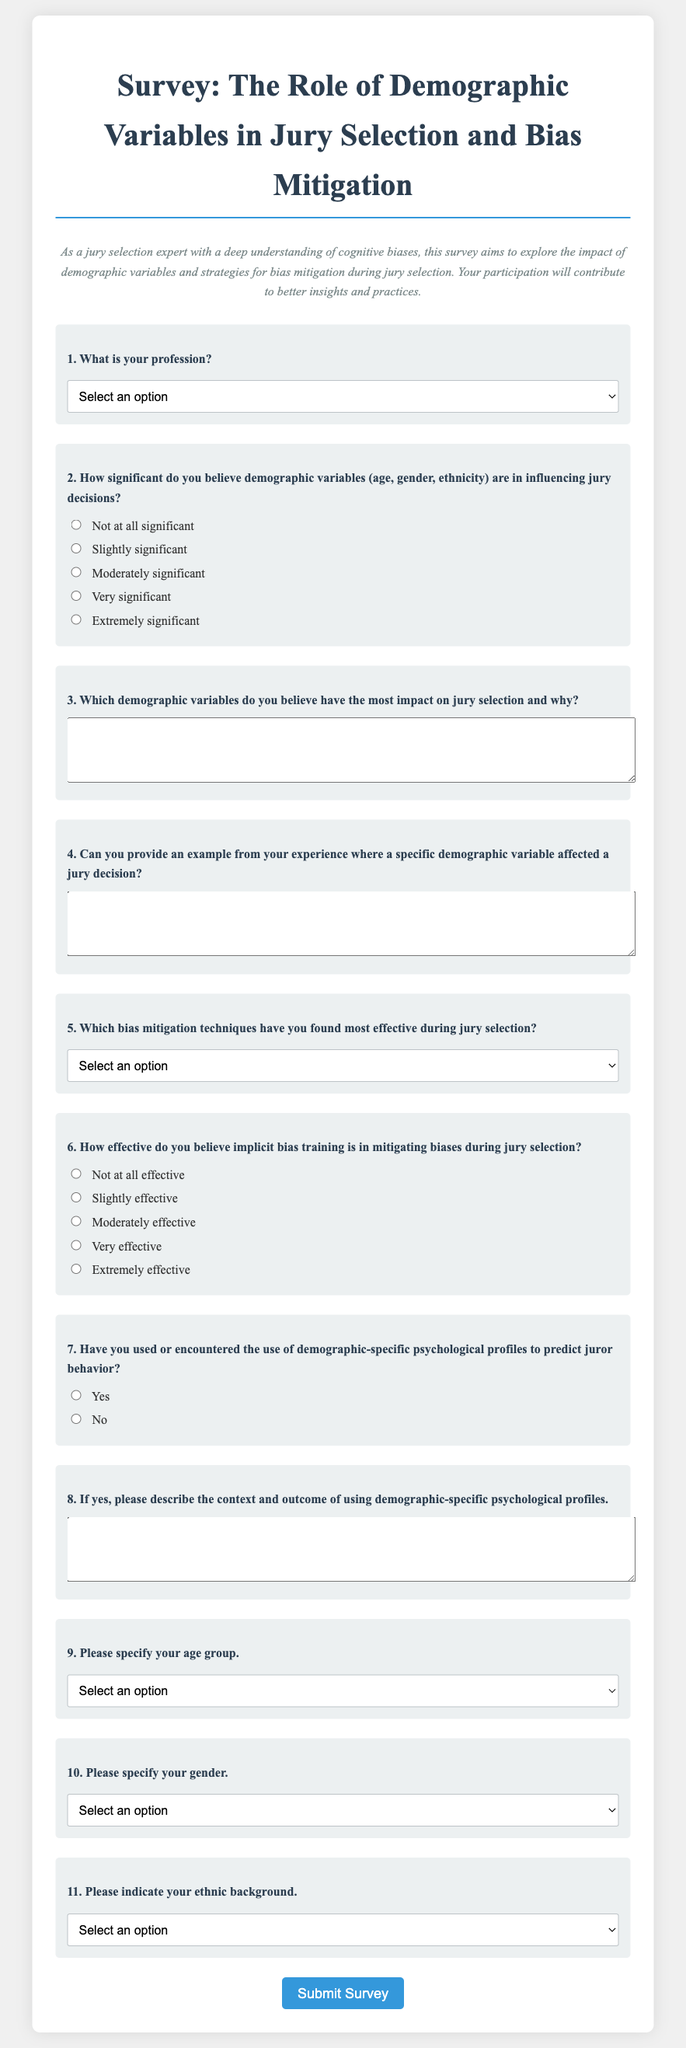What is the title of the survey? The title appears prominently at the top of the document, indicating the focus of the survey.
Answer: Survey: The Role of Demographic Variables in Jury Selection and Bias Mitigation How many demographic variables are mentioned in the significance question? The question explicitly refers to three specific demographic variables that influence jury decisions.
Answer: Three Which bias mitigation technique is listed first in the select options? The order of options in the survey provides a clear listing of techniques available for selection.
Answer: Randomized Juror Lists What age group option is provided for respondents? The survey features multiple age group categories for demographic collection.
Answer: 18-24 What is the required action for participants at the end of the survey? The last button indicates the action participants should take to submit their responses.
Answer: Submit Survey What is the purpose of this survey as stated in the description? The description clarifies the intent behind conducting the survey regarding jury selection and biases.
Answer: Explore the impact of demographic variables and strategies for bias mitigation during jury selection What is the required format for providing an example of demographic variable impact? The survey allows respondents to provide detailed qualitative answers in a specified area.
Answer: Text area How many response options are there for the effectiveness of implicit bias training question? The document categorizes the effectiveness into distinct levels for selection.
Answer: Five What is one of the professional roles listed as an option in the profession question? The question seeks to categorize respondents based on their professional backgrounds relevant to jury selection.
Answer: Lawyer 